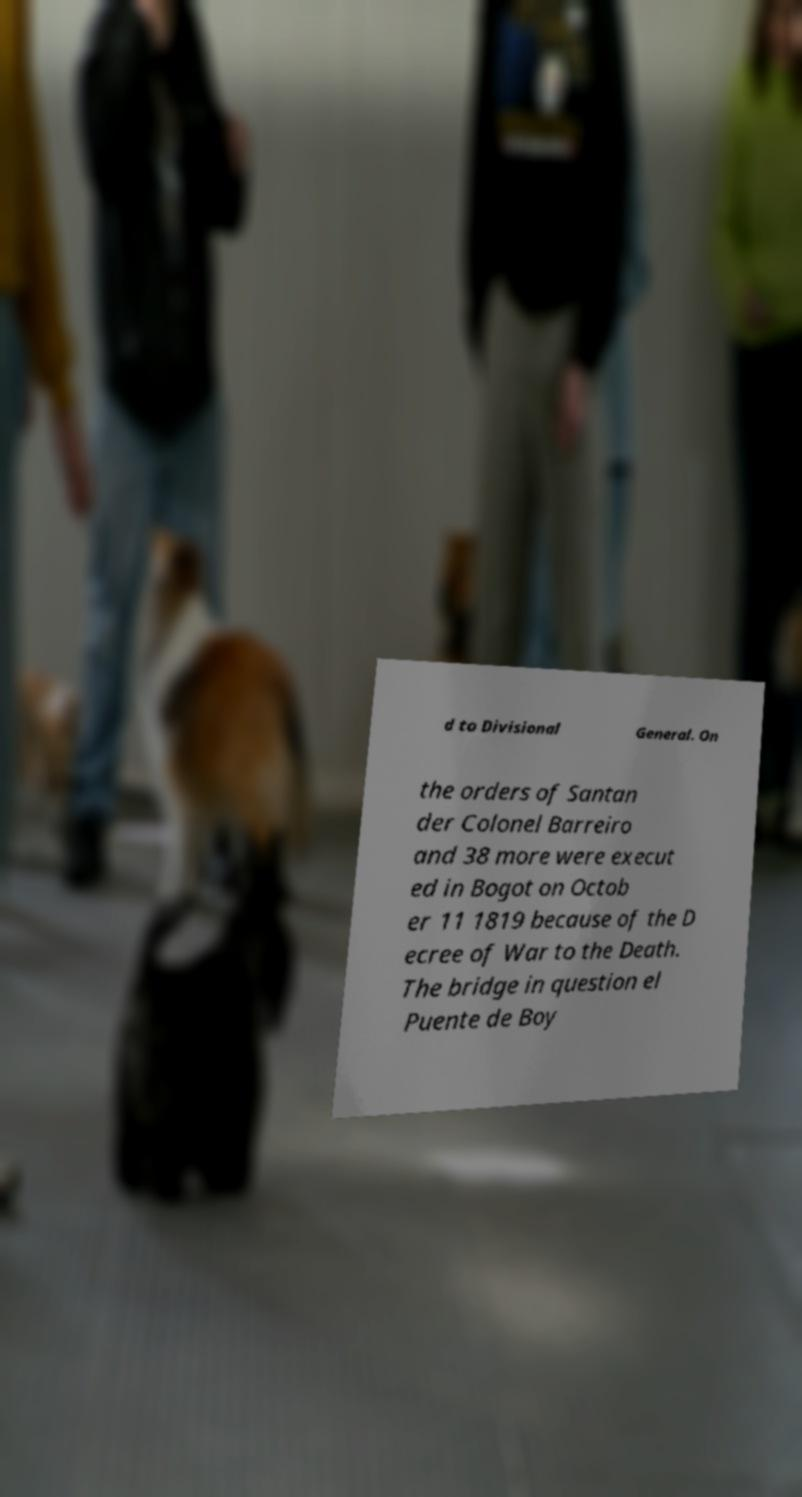I need the written content from this picture converted into text. Can you do that? d to Divisional General. On the orders of Santan der Colonel Barreiro and 38 more were execut ed in Bogot on Octob er 11 1819 because of the D ecree of War to the Death. The bridge in question el Puente de Boy 